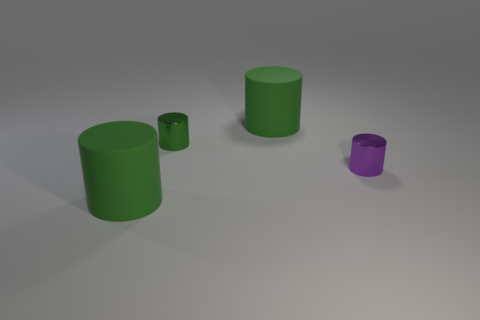How many green cylinders must be subtracted to get 1 green cylinders? 2 Subtract all red balls. How many green cylinders are left? 3 Add 2 tiny purple things. How many objects exist? 6 Subtract 0 gray balls. How many objects are left? 4 Subtract all tiny green metal cylinders. Subtract all tiny purple cylinders. How many objects are left? 2 Add 3 big cylinders. How many big cylinders are left? 5 Add 4 green matte cylinders. How many green matte cylinders exist? 6 